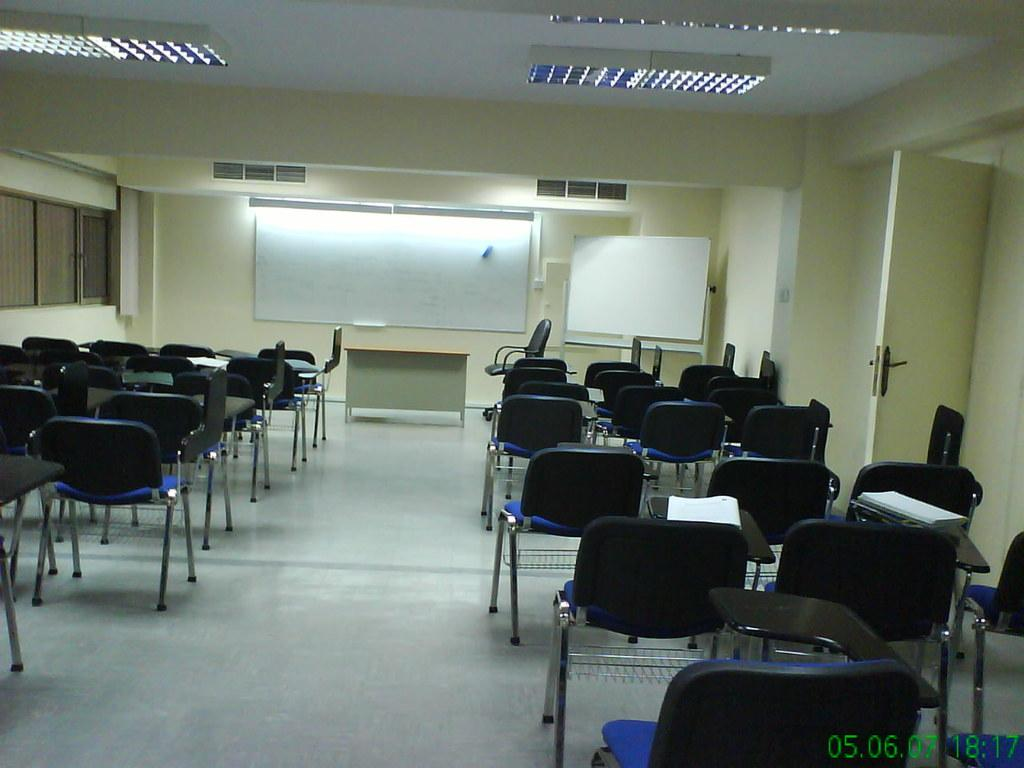What type of structure can be seen in the image? There is a wall in the image. What feature is present in the wall that allows for visibility? There is a window in the image. What is another object that can be seen on the wall? There is a board in the image. What is a common feature in buildings that can be seen in the image? There is a door in the image. What type of furniture is on the floor in the image? There are chairs on the floor in the image. What type of holiday is being celebrated in the image? There is no indication of a holiday being celebrated in the image. What year is depicted in the image? There is no indication of a specific year in the image. 